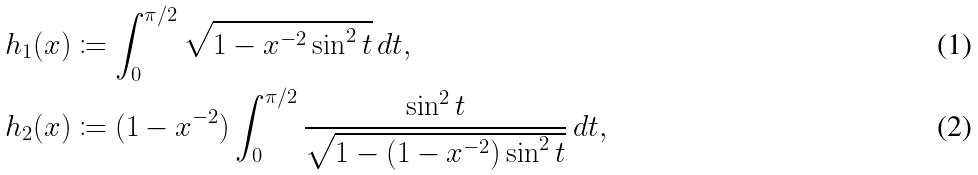Convert formula to latex. <formula><loc_0><loc_0><loc_500><loc_500>h _ { 1 } ( x ) & \coloneqq \int _ { 0 } ^ { \pi / 2 } \sqrt { 1 - x ^ { - 2 } \sin ^ { 2 } t } \, d t , \\ h _ { 2 } ( x ) & \coloneqq ( 1 - x ^ { - 2 } ) \int _ { 0 } ^ { \pi / 2 } \frac { \sin ^ { 2 } t } { \sqrt { 1 - ( 1 - x ^ { - 2 } ) \sin ^ { 2 } t } } \, d t ,</formula> 